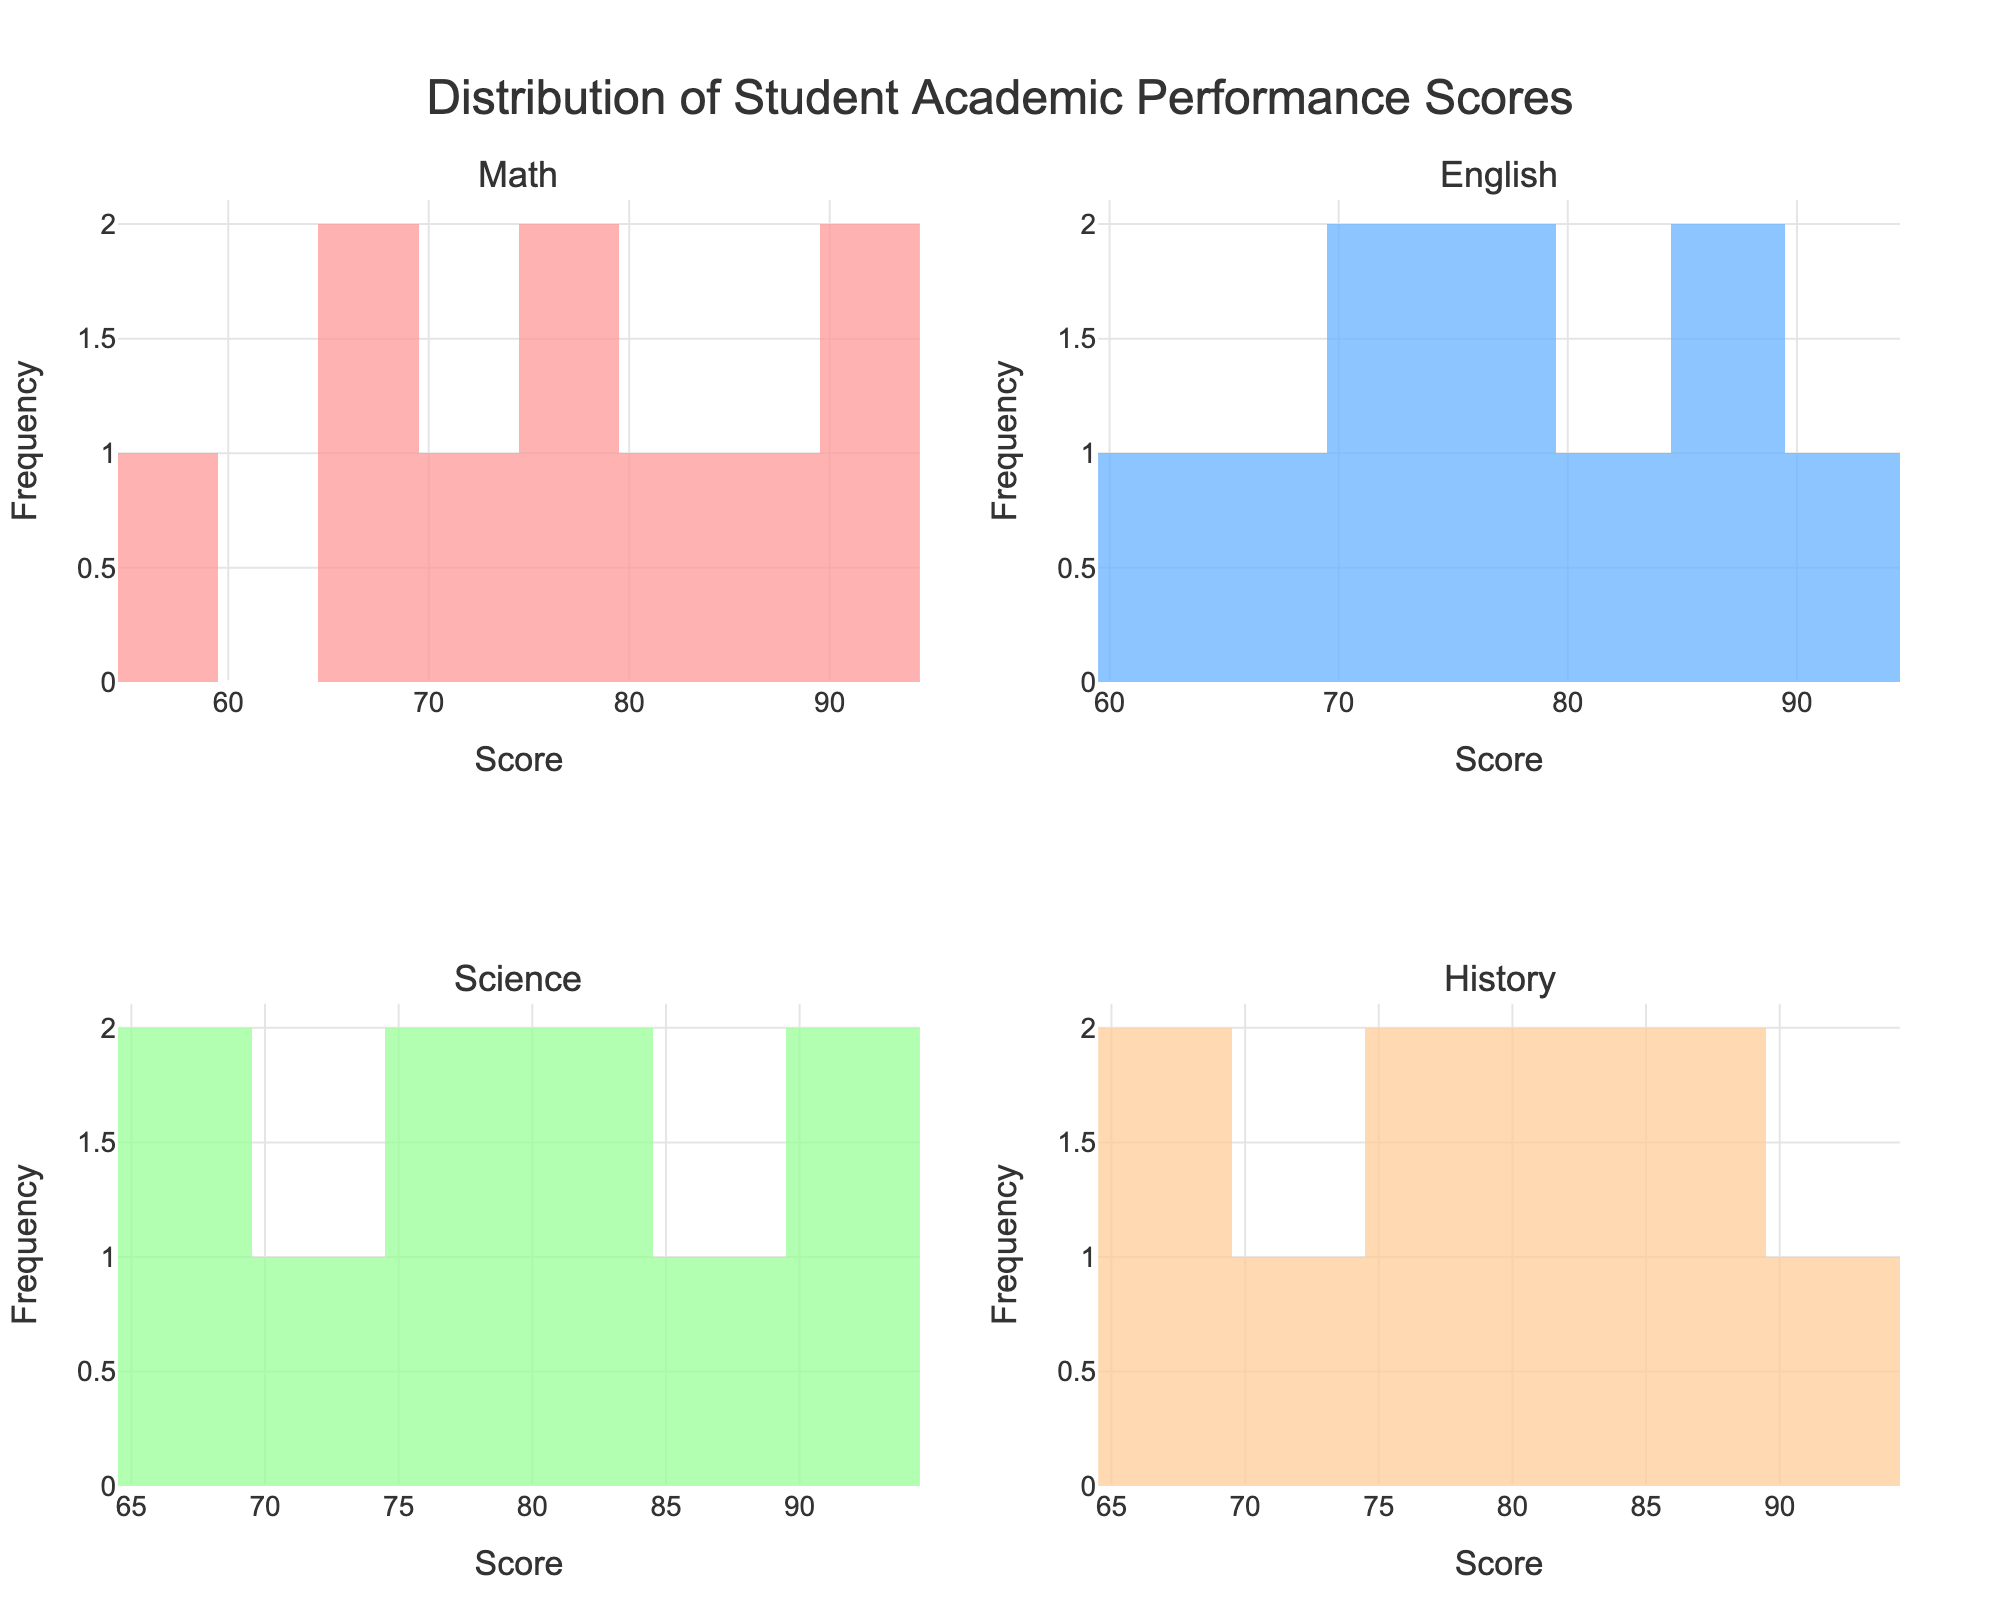- What is the title of the overall figure? The title is located at the top center of the figure. It reads "Distribution of Student Academic Performance Scores".
Answer: Distribution of Student Academic Performance Scores - How many subjects are represented in the plots? Each subplot represents a different subject and there are four subplots in total.
Answer: Four - What are the subjects included in the plots? The subplot titles show the names of the subjects. They are Math, English, Science, and History.
Answer: Math, English, Science, History - Which subject has the highest frequency of scores in the range 80-90? By looking at the histograms, the subject with the highest frequency of scores between 80-90 can be observed. English has 3 scores, Science has 3 scores, and History has 3 scores. When counts are equal, we'll mention them all.
Answer: English, Science, History - Which subject has the lowest highest score? The highest score for each subject can be found from the rightmost bin in each histogram. Math has a highest score of 93, English has 91, Science has 94, History has 92. The subject with the lowest highest score is English.
Answer: English - What is the range of scores for Science? The range is determined by subtracting the smallest score from the highest score observed in the Science histogram. The highest score is 94 and the lowest score is 65. 94 - 65 = 29.
Answer: 29 - How many bins are used for each histogram? The histograms use bins to group the scores. By counting the bars in any of the subplots, it can be observed that each histogram uses 10 bins.
Answer: 10 - In which subject do students have the most evenly distributed scores? Even distribution means that frequencies across score ranges are close to each other. The subject with the most evenly distributed scores can be seen by comparing the heights of bars in each histogram. Math shows relatively evenly distributed scores.
Answer: Math - Which subject has scores with the highest concentration in a single bin? Looking at the histograms to find the bin with the highest bar will show which subject has the highest concentration. Science shows the highest bin around 9 in the 70-80 range.
Answer: Science - Between Math and History, which subject shows a wider variability in scores? Variability can be judged by looking at the spread of scores in the histograms. Math's scores range from 55 to 93, and History's scores range from 67 to 92, indicating Math has a wider variability.
Answer: Math 